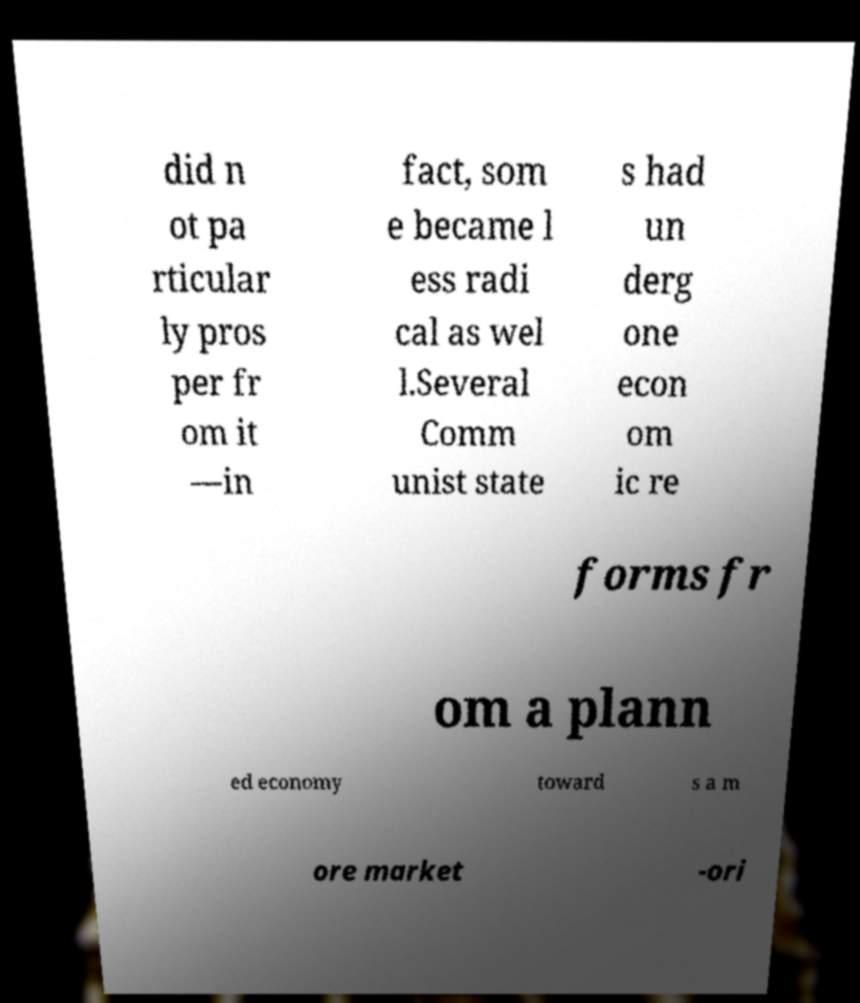Could you assist in decoding the text presented in this image and type it out clearly? did n ot pa rticular ly pros per fr om it —in fact, som e became l ess radi cal as wel l.Several Comm unist state s had un derg one econ om ic re forms fr om a plann ed economy toward s a m ore market -ori 